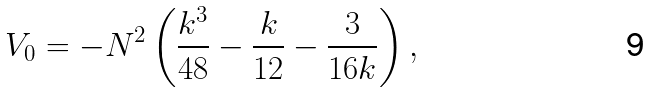Convert formula to latex. <formula><loc_0><loc_0><loc_500><loc_500>V _ { 0 } = - N ^ { 2 } \left ( \frac { k ^ { 3 } } { 4 8 } - \frac { k } { 1 2 } - \frac { 3 } { 1 6 k } \right ) ,</formula> 